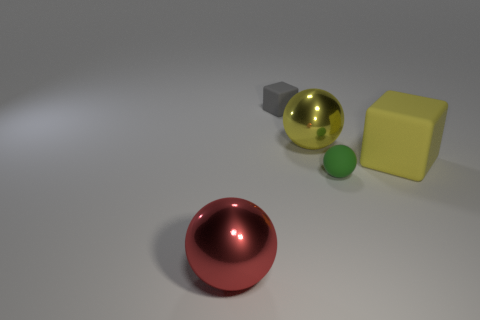Add 4 large shiny spheres. How many objects exist? 9 Subtract all blocks. How many objects are left? 3 Subtract 0 blue blocks. How many objects are left? 5 Subtract all tiny gray objects. Subtract all tiny metallic objects. How many objects are left? 4 Add 4 large matte cubes. How many large matte cubes are left? 5 Add 1 large red balls. How many large red balls exist? 2 